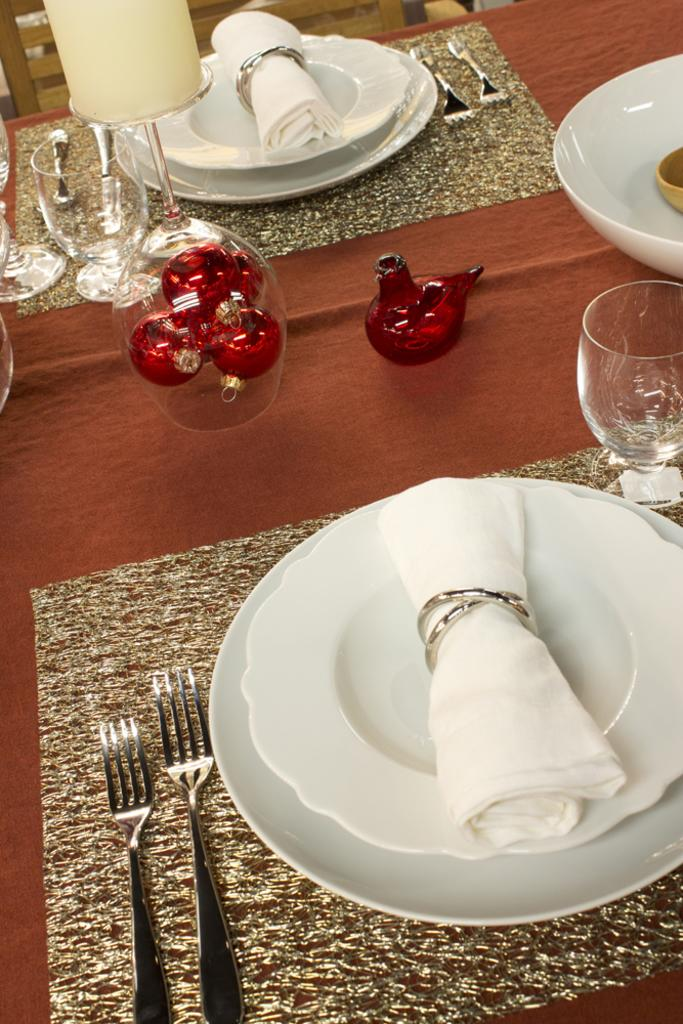What piece of furniture is visible in the image? There is a table in the image. What is placed on the table? There is a plate, tissues, a fork, a glass, and a bowl on the table. Can you describe the lighting in the image? There is a light in the image. What type of seating is present in the image? There is a chair in the image. Is there any living creature visible in the image? Yes, there is a bird in the image. What is the lawyer's income in the image? There is no lawyer or information about income present in the image. How many bags of popcorn are on the table in the image? There is no popcorn present in the image. 